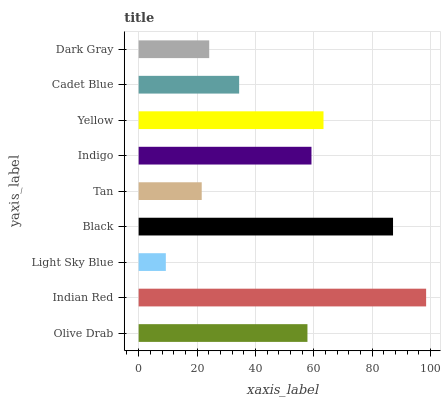Is Light Sky Blue the minimum?
Answer yes or no. Yes. Is Indian Red the maximum?
Answer yes or no. Yes. Is Indian Red the minimum?
Answer yes or no. No. Is Light Sky Blue the maximum?
Answer yes or no. No. Is Indian Red greater than Light Sky Blue?
Answer yes or no. Yes. Is Light Sky Blue less than Indian Red?
Answer yes or no. Yes. Is Light Sky Blue greater than Indian Red?
Answer yes or no. No. Is Indian Red less than Light Sky Blue?
Answer yes or no. No. Is Olive Drab the high median?
Answer yes or no. Yes. Is Olive Drab the low median?
Answer yes or no. Yes. Is Black the high median?
Answer yes or no. No. Is Tan the low median?
Answer yes or no. No. 